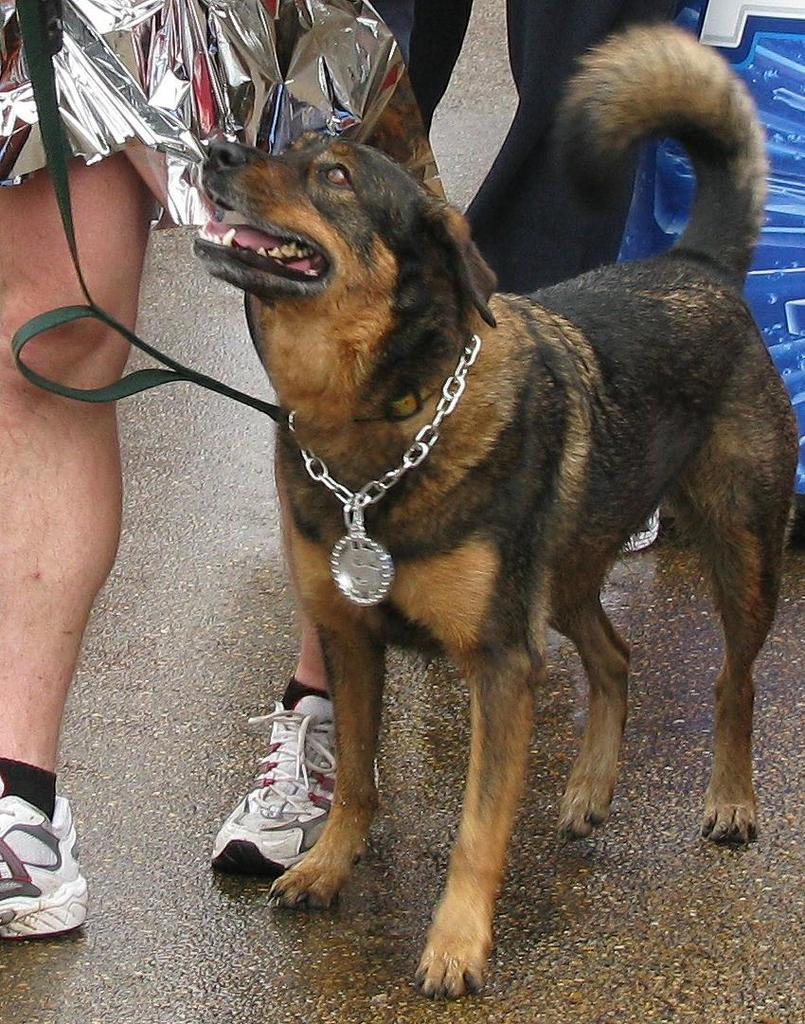How many people are present in the image? There are people in the image, but the exact number is not specified. What type of animal is in the image? There is a dog in the image. What can be seen in the background of the image? There is a board in the background of the image. What is at the bottom of the image? There is a walkway at the bottom of the image. What object is being held by one of the people in the image? One person is holding a belt in the image. What type of authority figure is present in the image? There is no mention of an authority figure in the image. Can you hear a song playing in the background of the image? The image is static, so there is no sound or song present. 